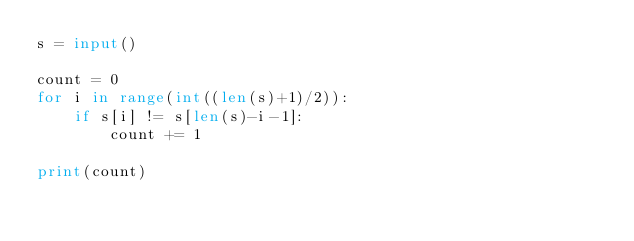Convert code to text. <code><loc_0><loc_0><loc_500><loc_500><_Python_>s = input()

count = 0
for i in range(int((len(s)+1)/2)):
    if s[i] != s[len(s)-i-1]:
        count += 1

print(count)
</code> 